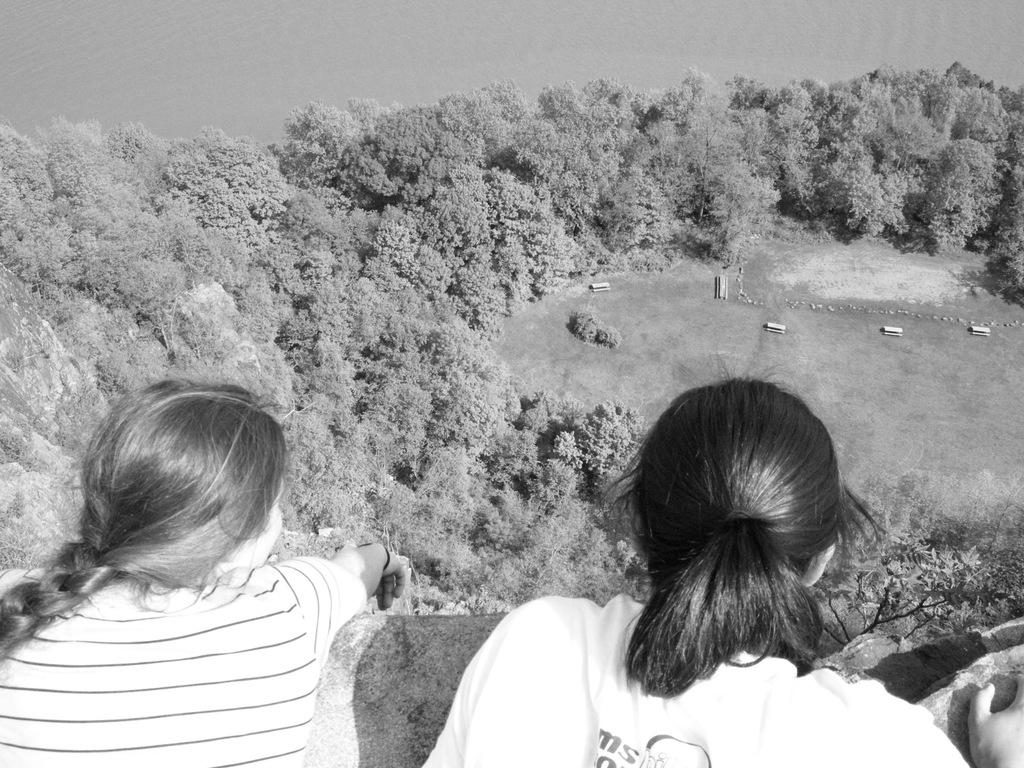How many people are in the image? There are two women in the image. What type of natural elements can be seen in the image? There are trees in the image. What can be seen in the background of the image? Vehicles are visible in the background of the image. What is the color scheme of the image? The image is black and white in color. What type of pet is sitting on the page in the image? There is no pet or page present in the image. 